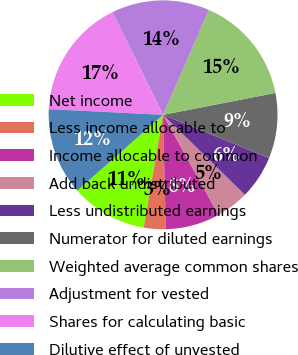<chart> <loc_0><loc_0><loc_500><loc_500><pie_chart><fcel>Net income<fcel>Less income allocable to<fcel>Income allocable to common<fcel>Add back undistributed<fcel>Less undistributed earnings<fcel>Numerator for diluted earnings<fcel>Weighted average common shares<fcel>Adjustment for vested<fcel>Shares for calculating basic<fcel>Dilutive effect of unvested<nl><fcel>10.77%<fcel>3.08%<fcel>7.69%<fcel>4.62%<fcel>6.15%<fcel>9.23%<fcel>15.38%<fcel>13.85%<fcel>16.92%<fcel>12.31%<nl></chart> 